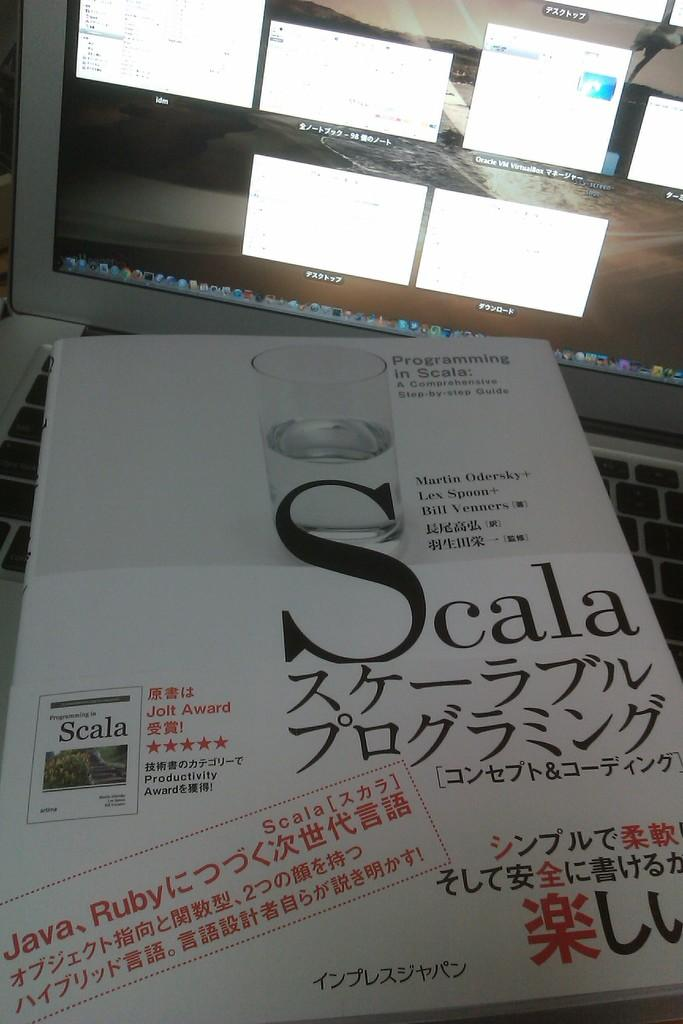<image>
Write a terse but informative summary of the picture. Paper saying Scala on top of a laptop. 